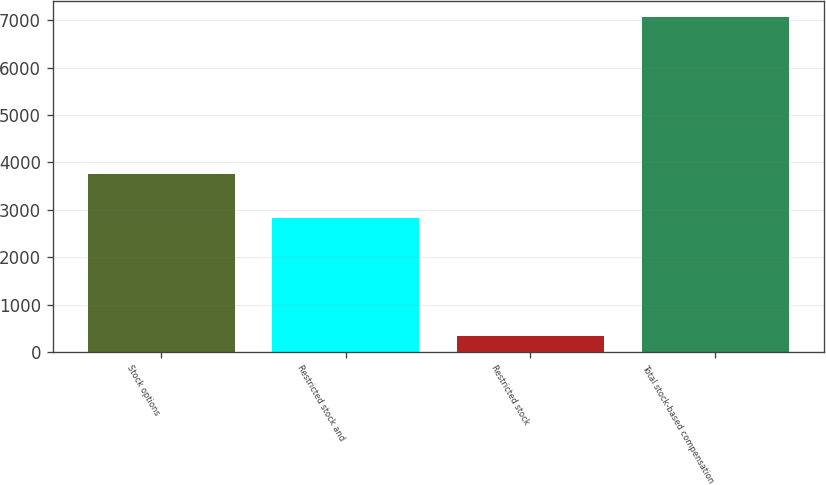Convert chart. <chart><loc_0><loc_0><loc_500><loc_500><bar_chart><fcel>Stock options<fcel>Restricted stock and<fcel>Restricted stock<fcel>Total stock-based compensation<nl><fcel>3757<fcel>2832<fcel>333<fcel>7061<nl></chart> 